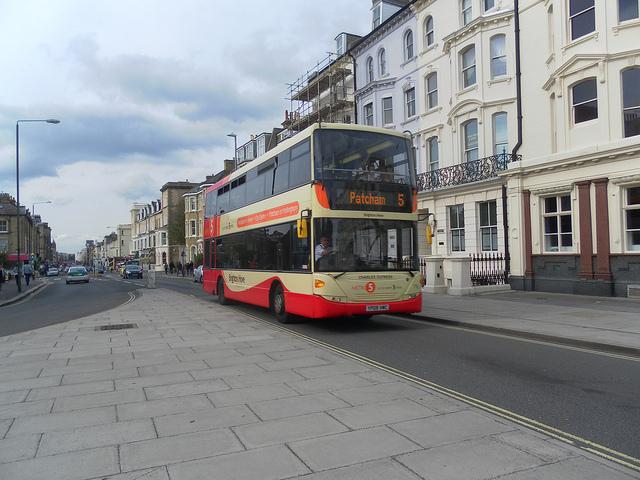What color is the bus?
Be succinct. Tan and red. Do the buildings have balconies?
Keep it brief. Yes. What kind of car is parked on the far right?
Short answer required. Bus. What number bus is this?
Be succinct. 5. Are all the houses white?
Concise answer only. Yes. About how many passengers are able to fit into this double Decker?
Be succinct. 100. 